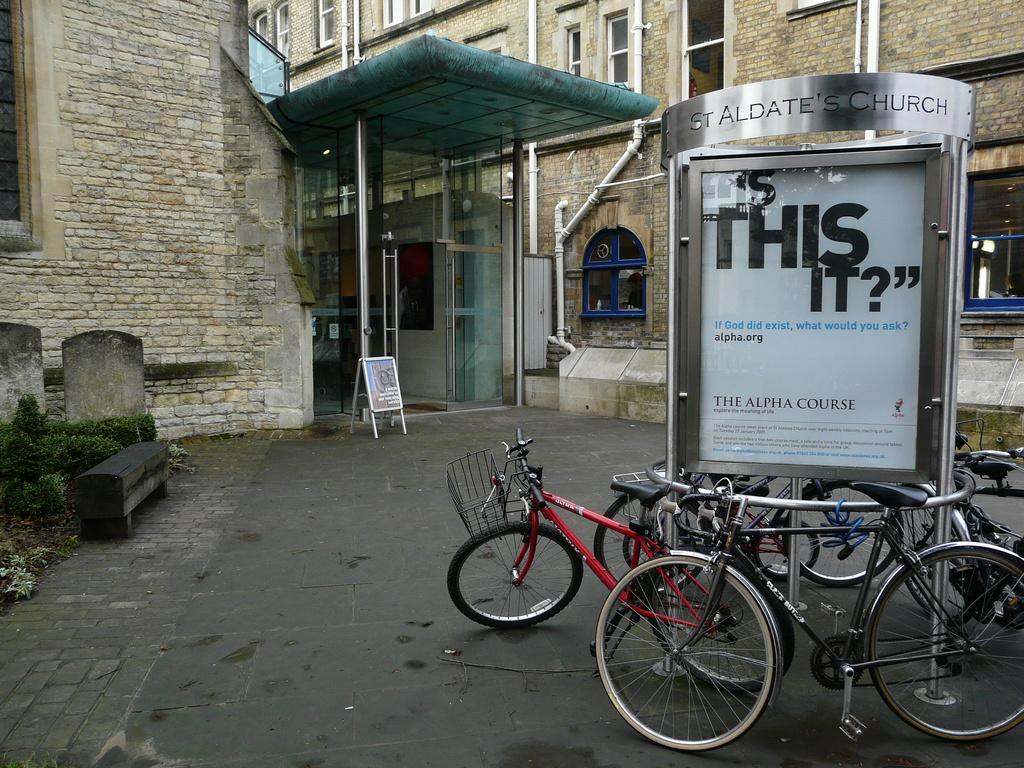What type of structures can be seen in the image? There are buildings in the image. What mode of transportation is visible in the image? There are bicycles in the image. What objects are present in the image that could be used for displaying information or advertisements? There are boards in the image. What type of vegetation is on the left side of the image? There are shrubs on the left side of the image. What is the average income of the people living in the alley depicted in the image? There is no alley present in the image, and therefore no information about the income of the people living there can be provided. 